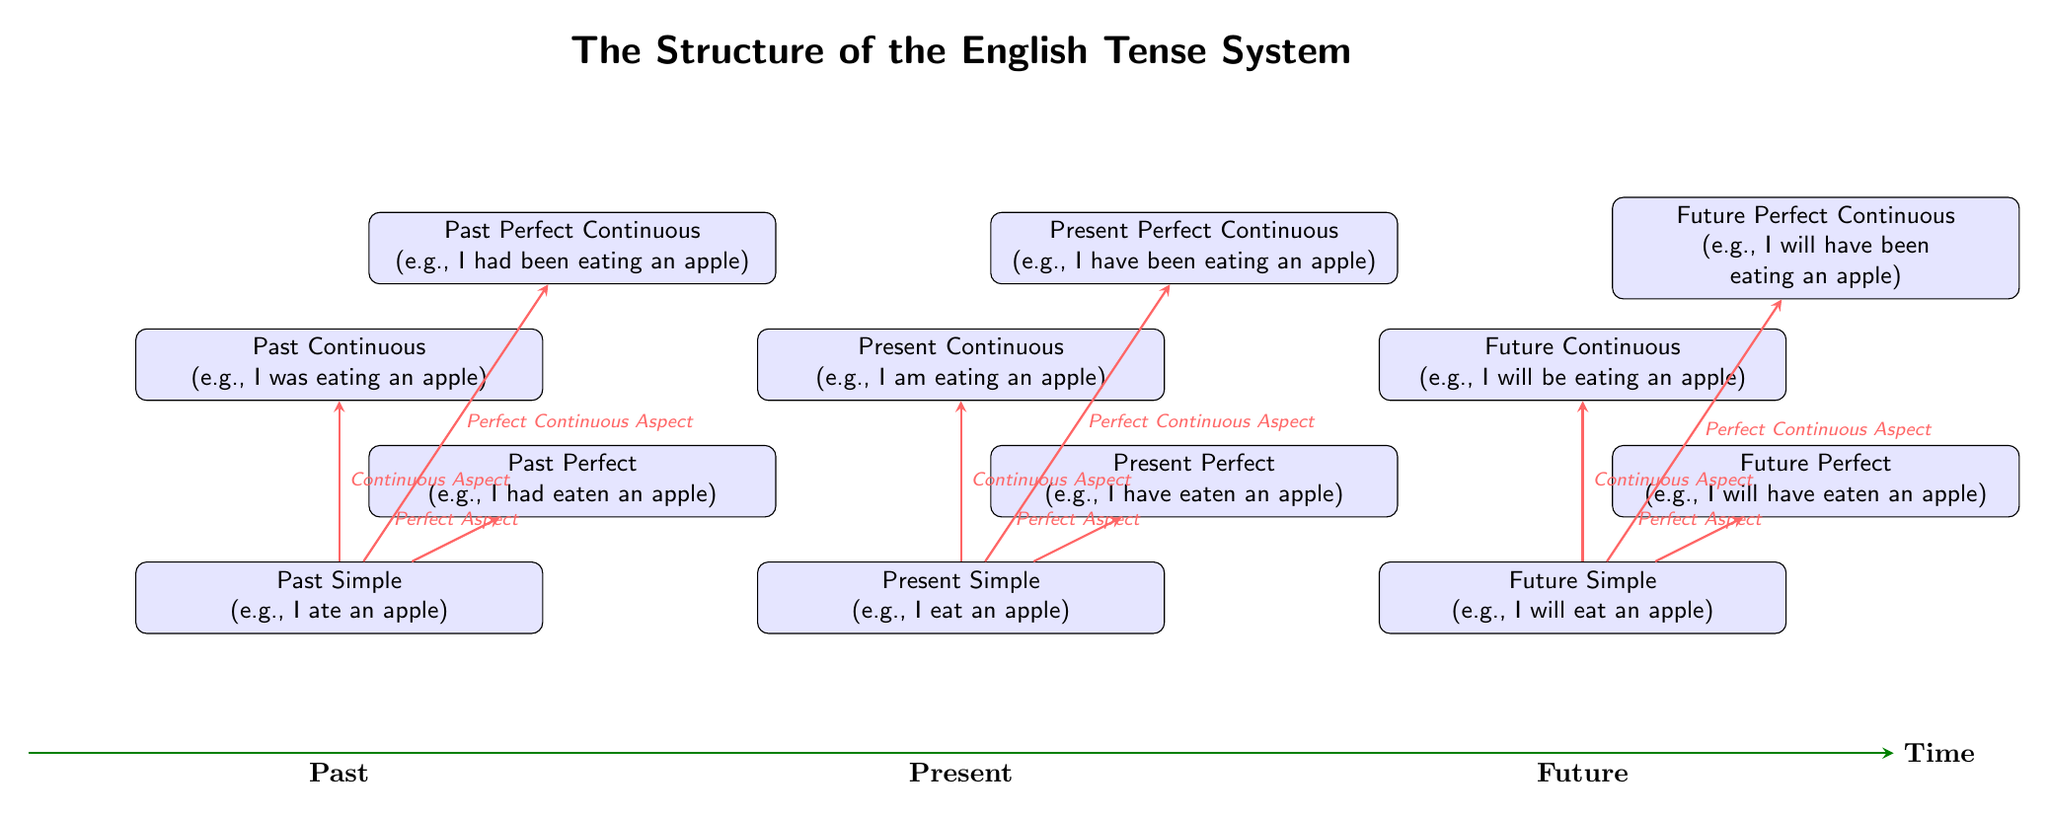What tense is represented at (0, 2)? By locating the coordinates (0, 2) on the diagram, we find the node labeled "Present Simple." This is confirmed by cross-referencing the positioned elements in the diagram.
Answer: Present Simple How many future tenses are shown in the diagram? The diagram illustrates three future tenses, which can be counted by reviewing the tense nodes in the future section indicated at the right side of the time axis.
Answer: 3 Which tense has the perfect aspect in the present time? The node for Present Perfect, positioned at (3, 3.5), corresponds to the perfect aspect related to the present tense. It can be identified by looking for the node titles and their respective positions in the present tense area.
Answer: Present Perfect What is the relationship between Past Simple and Past Continuous? The diagram illustrates that Past Simple is connected to Past Continuous through an aspect arrow labeled "Continuous Aspect." Following the directional line leads from Past Simple to Past Continuous.
Answer: Continuous Aspect Which tense is placed furthest to the right in the diagram? By examining the positioning of the nodes, Future Perfect, located at (11, 3.5), is the one that lies the furthest to the right along the timeline, corresponding with future tense aspects.
Answer: Future Perfect What aspects are associated with Past Simple? Reviewing the diagram, we see Past Simple branches out to three aspects: Continuous Aspect, Perfect Aspect, and Perfect Continuous Aspect. This relationship is established through the arrows connecting the nodes.
Answer: Continuous Aspect, Perfect Aspect, Perfect Continuous Aspect How many total tenses are depicted in the diagram? The total number of tenses can be determined by counting all nodes in the diagram: 12 distinct tense nodes are arranged across the past, present, and future categories.
Answer: 12 Which node is directly above the Past Perfect? According to the diagram's layout, the node directly above Past Perfect is Past Perfect Continuous, positioned at (-5, 6.5). This can be verified by the vertical alignment of the nodes in the past tense section.
Answer: Past Perfect Continuous What is the tense for the example "I was eating an apple"? The example "I was eating an apple" corresponds to the Past Continuous tense, found at (-8, 5) on the diagram. This is identified by referencing the examples provided alongside each tense node.
Answer: Past Continuous 